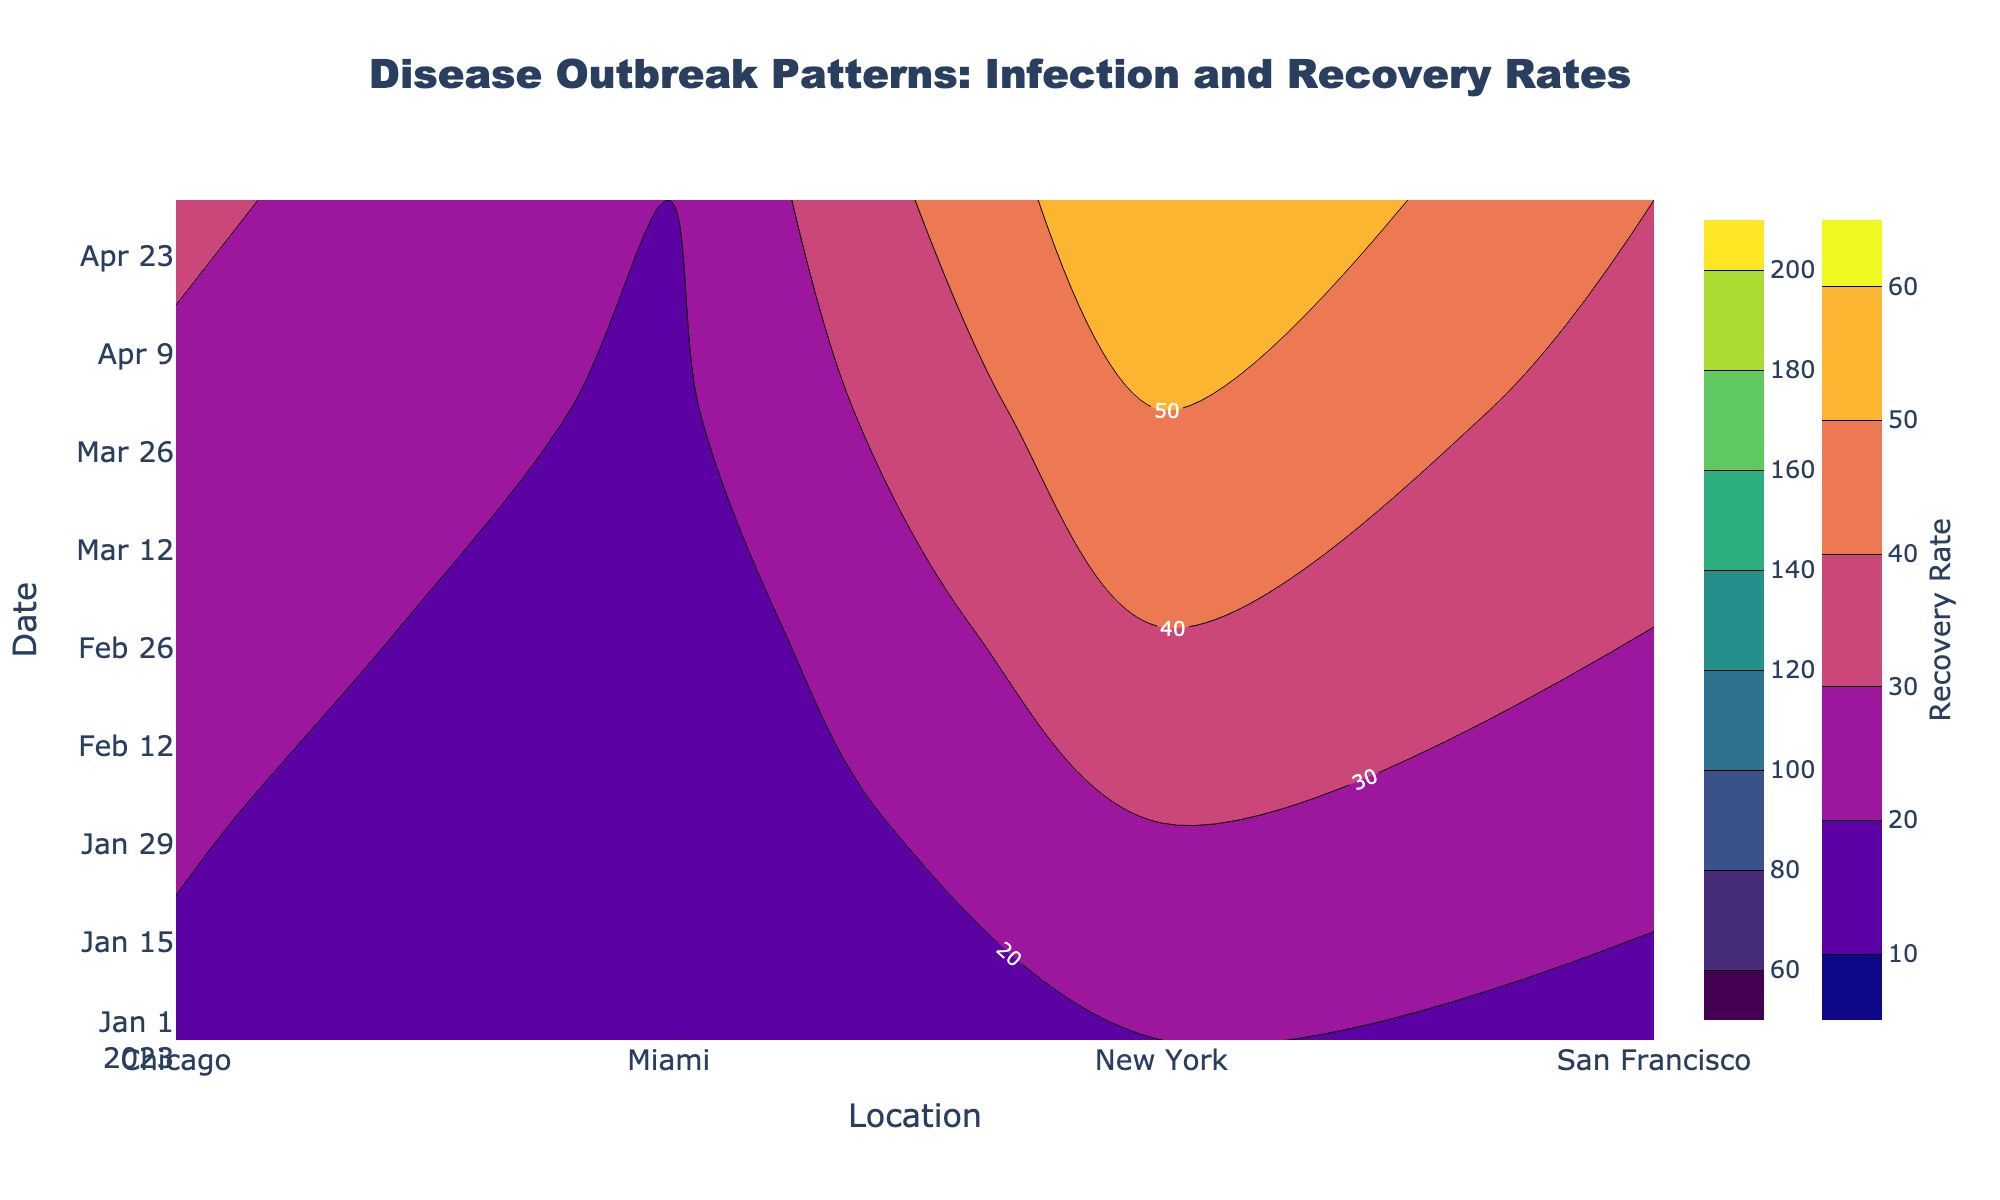What is the title of the figure? The title of the figure is displayed at the top of the plot and is explicitly provided as "Disease Outbreak Patterns: Infection and Recovery Rates".
Answer: Disease Outbreak Patterns: Infection and Recovery Rates What is the background color of the plot? The background color of the plot is mentioned in the layout configuration as 'rgba(240,240,240,0.8)', which equates to a light grey color.
Answer: Light grey Which date shows the highest infection rate in New York? To find the highest infection rate in New York, look for the contour label with the highest number within the 'New York' column of the Infection Rate contour plot.
Answer: 2023-05-01 What is the average recovery rate in Miami across all dates? The recovery rates in Miami are 10, 12, 14, 18, and 20. The average is calculated by summing these values and dividing by the number of entries: (10 + 12 + 14 + 18 + 20) / 5 = 74 / 5 = 14.8.
Answer: 14.8 How does the infection rate in San Francisco on 2023-04-01 compare to that in Chicago on the same date? Locate 2023-04-01 on the y-axis and compare the contour labels for 'San Francisco' and 'Chicago'. San Francisco's infection rate is 130, and Chicago's is 160. Therefore, Chicago's rate is higher.
Answer: Chicago's rate is higher Does the recovery rate in New York increase or decrease over time? Trace the contour labels for the 'Recovery Rate' in New York across the timeline. The recovery rates are 20, 30, 40, 50, and 60, which shows an increasing trend.
Answer: Increase What is the difference in the infection rate between Miami and New York on 2023-03-01? On 2023-03-01, Miami has an infection rate of 80 and New York has an infection rate of 170. The difference is 170 - 80 = 90.
Answer: 90 Which location has the lowest recovery rate on 2023-05-01? Locate the date 2023-05-01 on the y-axis and examine the contour labels for the 'Recovery Rate' across all locations. Miami has the lowest rate at 20.
Answer: Miami By how much does the infection rate in Chicago increase from 2023-02-01 to 2023-05-01? The infection rate in Chicago on 2023-02-01 is 120 and on 2023-05-01 is 180. The increase is calculated as 180 - 120 = 60.
Answer: 60 